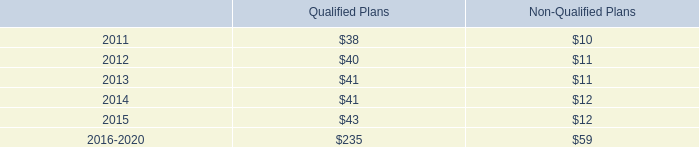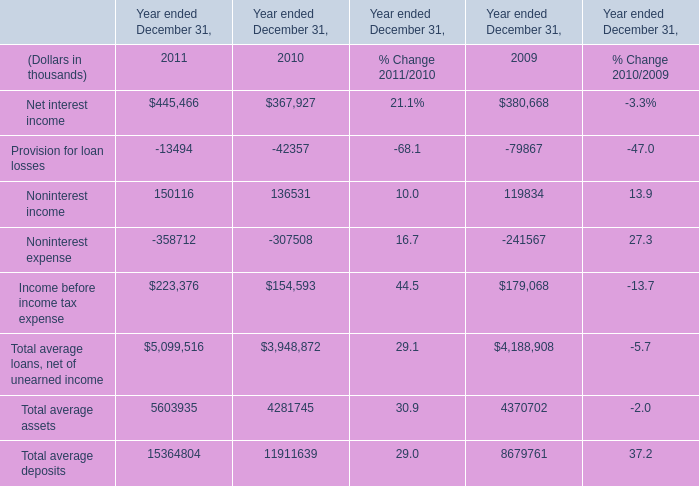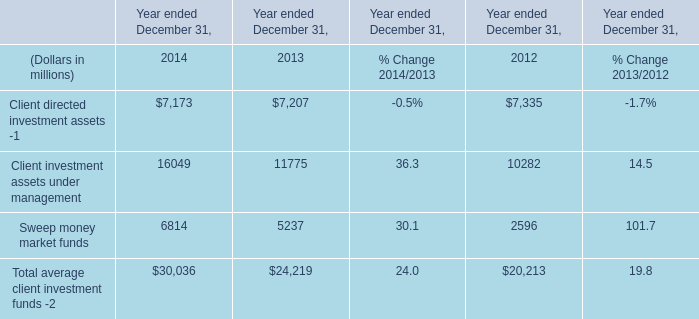What is the sum of Sweep money market funds of Year ended December 31, 2012, Provision for loan losses of Year ended December 31, 2009, and Net interest income of Year ended December 31, 2010 ? 
Computations: ((2596.0 + 79867.0) + 367927.0)
Answer: 450390.0. 